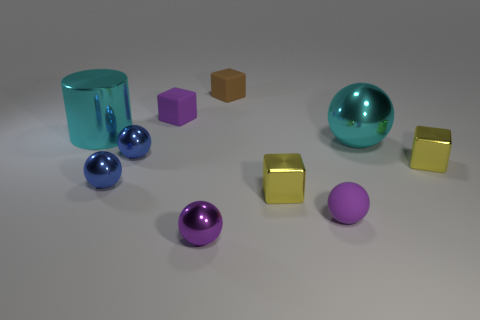What is the texture of the objects in the middle of the scene? The objects in the middle, which include a purple matte sphere and a yellow metallic cube, exhibit contrasting textures; the sphere has a matte finish while the cube has a shiny metallic surface.  What can you infer about the light source in this image? The light source in this image appears to be coming from above, as indicated by the shadows beneath the objects, which fall slightly to the left side, suggesting that the light is directional and not directly overhead. 